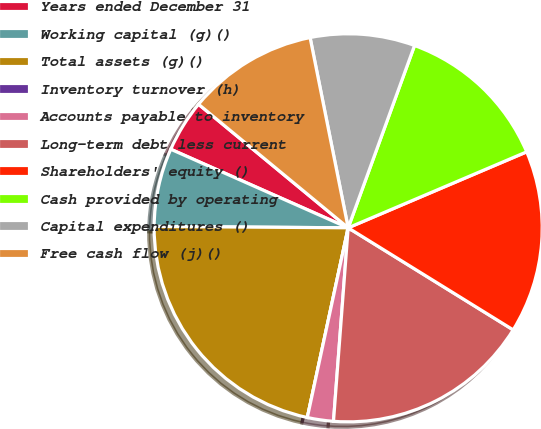Convert chart. <chart><loc_0><loc_0><loc_500><loc_500><pie_chart><fcel>Years ended December 31<fcel>Working capital (g)()<fcel>Total assets (g)()<fcel>Inventory turnover (h)<fcel>Accounts payable to inventory<fcel>Long-term debt less current<fcel>Shareholders' equity ()<fcel>Cash provided by operating<fcel>Capital expenditures ()<fcel>Free cash flow (j)()<nl><fcel>4.35%<fcel>6.52%<fcel>21.74%<fcel>0.0%<fcel>2.17%<fcel>17.39%<fcel>15.22%<fcel>13.04%<fcel>8.7%<fcel>10.87%<nl></chart> 